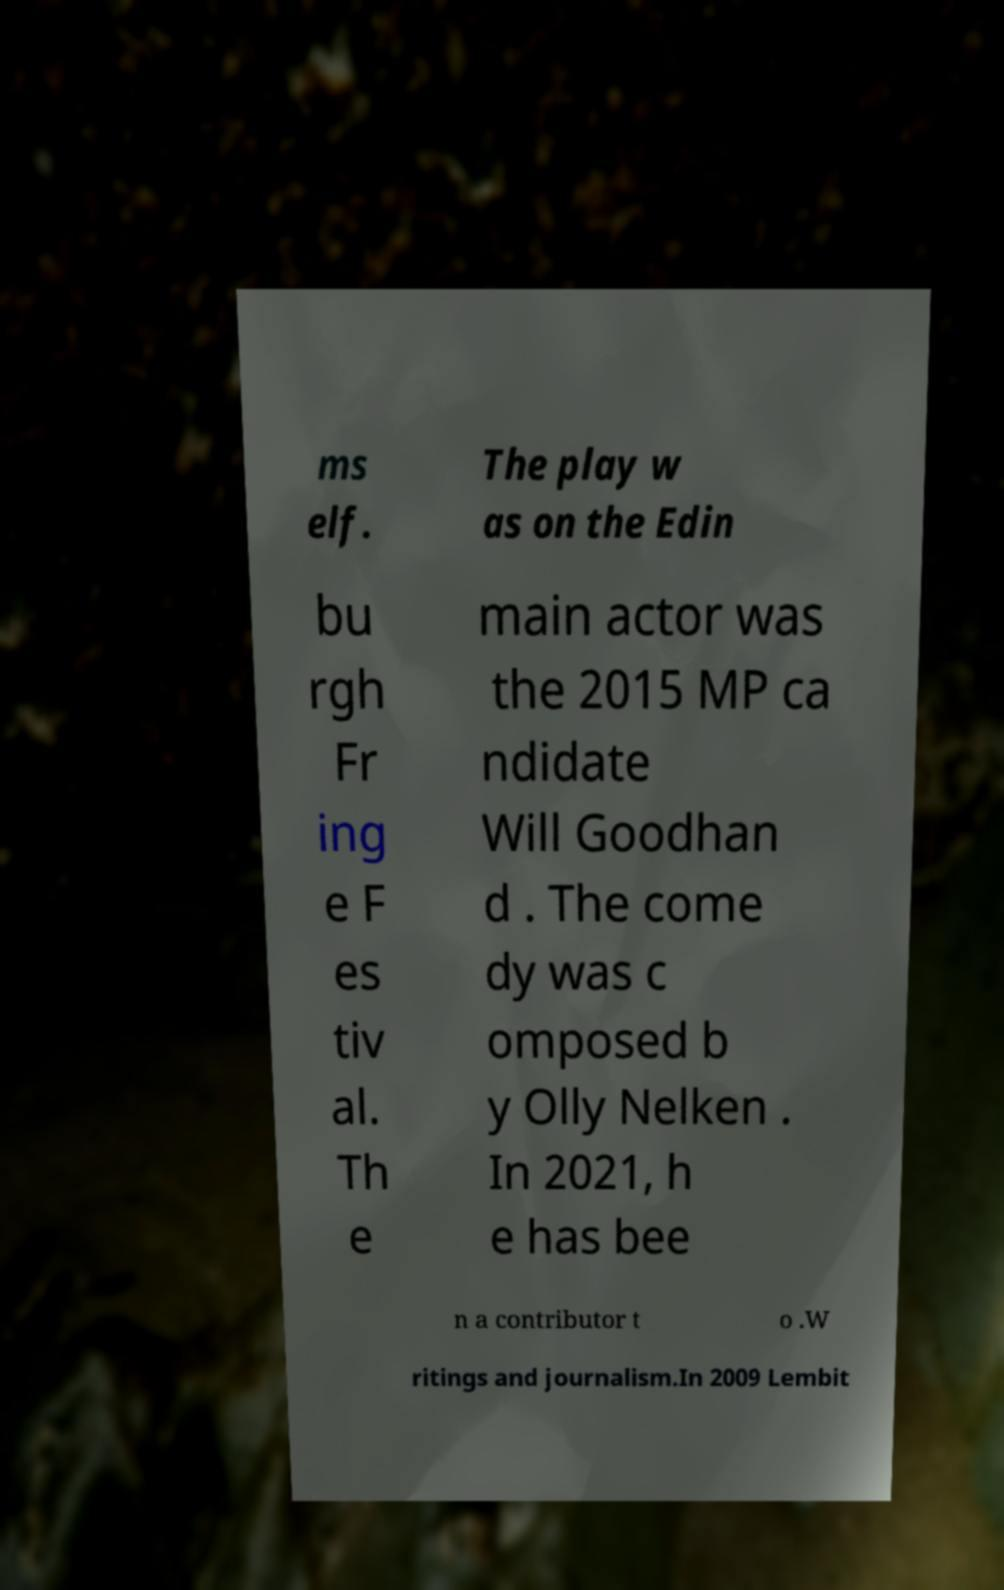Can you read and provide the text displayed in the image?This photo seems to have some interesting text. Can you extract and type it out for me? ms elf. The play w as on the Edin bu rgh Fr ing e F es tiv al. Th e main actor was the 2015 MP ca ndidate Will Goodhan d . The come dy was c omposed b y Olly Nelken . In 2021, h e has bee n a contributor t o .W ritings and journalism.In 2009 Lembit 